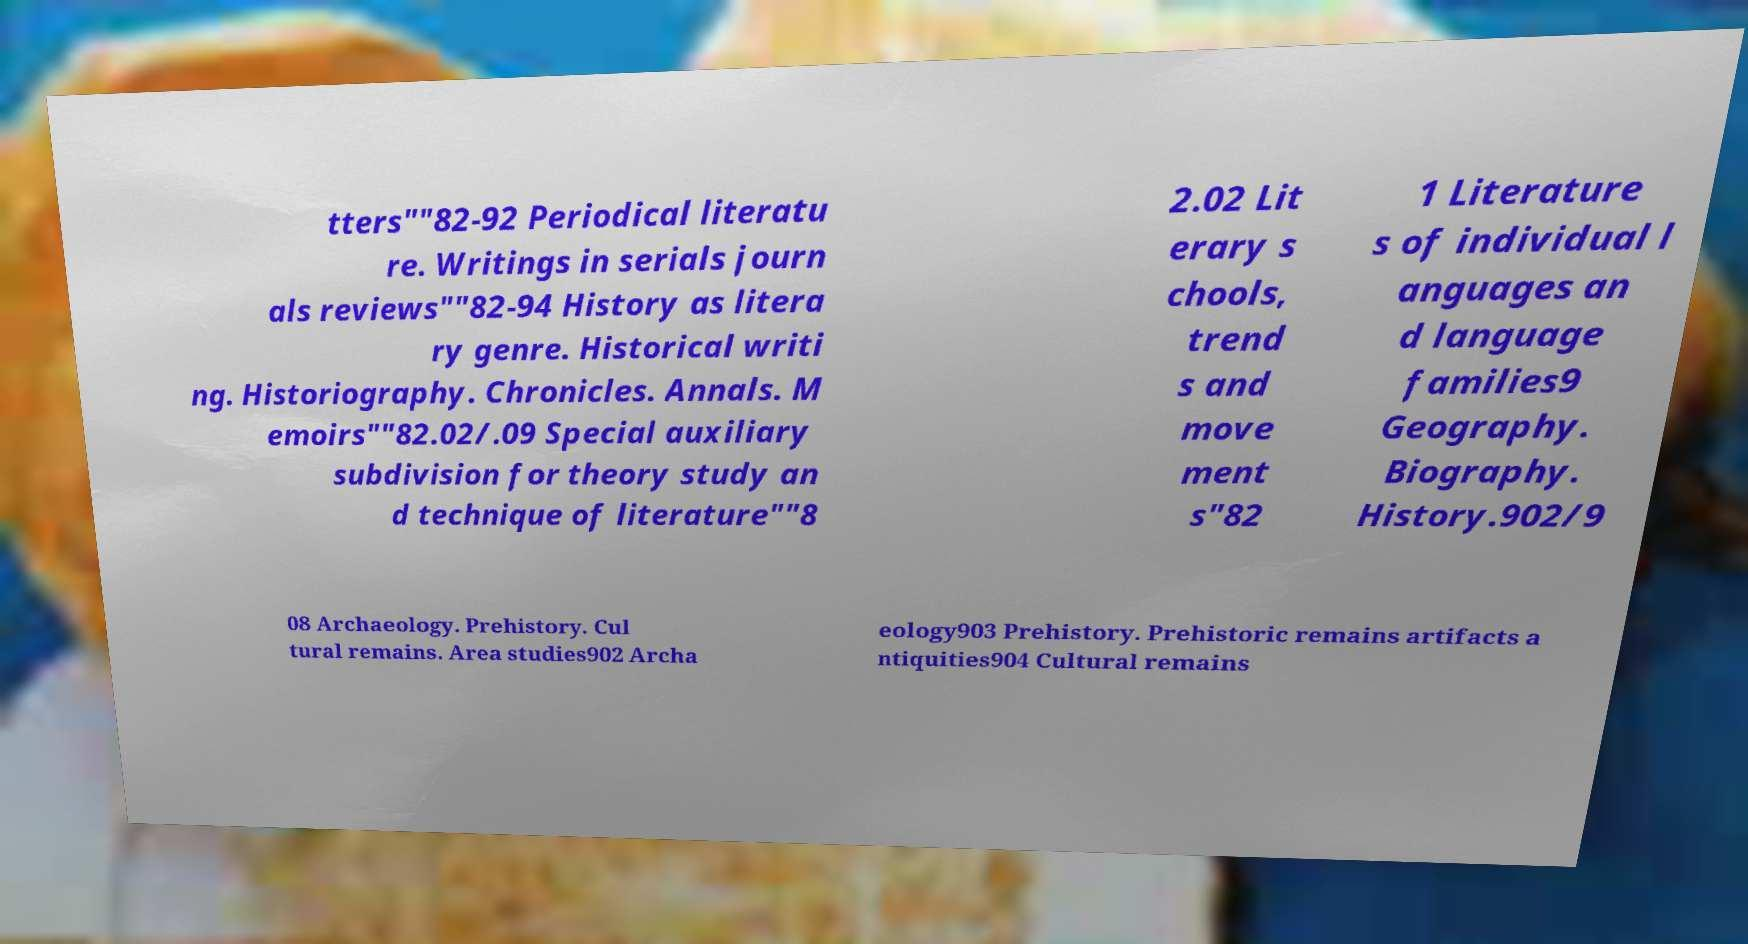Please read and relay the text visible in this image. What does it say? tters""82-92 Periodical literatu re. Writings in serials journ als reviews""82-94 History as litera ry genre. Historical writi ng. Historiography. Chronicles. Annals. M emoirs""82.02/.09 Special auxiliary subdivision for theory study an d technique of literature""8 2.02 Lit erary s chools, trend s and move ment s"82 1 Literature s of individual l anguages an d language families9 Geography. Biography. History.902/9 08 Archaeology. Prehistory. Cul tural remains. Area studies902 Archa eology903 Prehistory. Prehistoric remains artifacts a ntiquities904 Cultural remains 